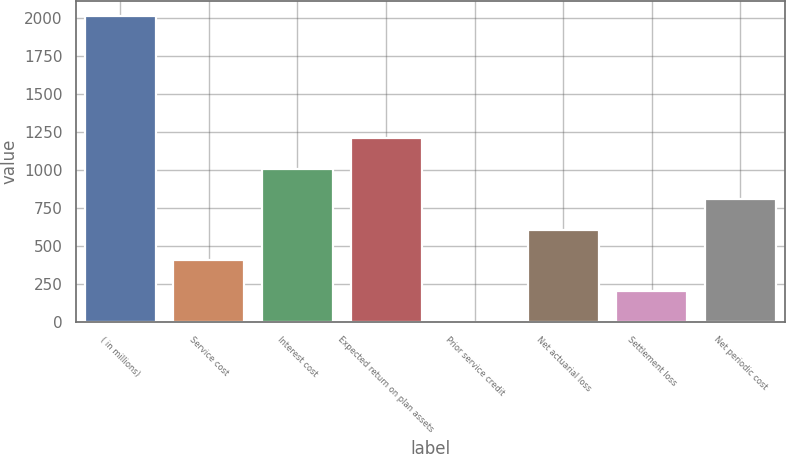<chart> <loc_0><loc_0><loc_500><loc_500><bar_chart><fcel>( in millions)<fcel>Service cost<fcel>Interest cost<fcel>Expected return on plan assets<fcel>Prior service credit<fcel>Net actuarial loss<fcel>Settlement loss<fcel>Net periodic cost<nl><fcel>2011<fcel>403.8<fcel>1006.5<fcel>1207.4<fcel>2<fcel>604.7<fcel>202.9<fcel>805.6<nl></chart> 